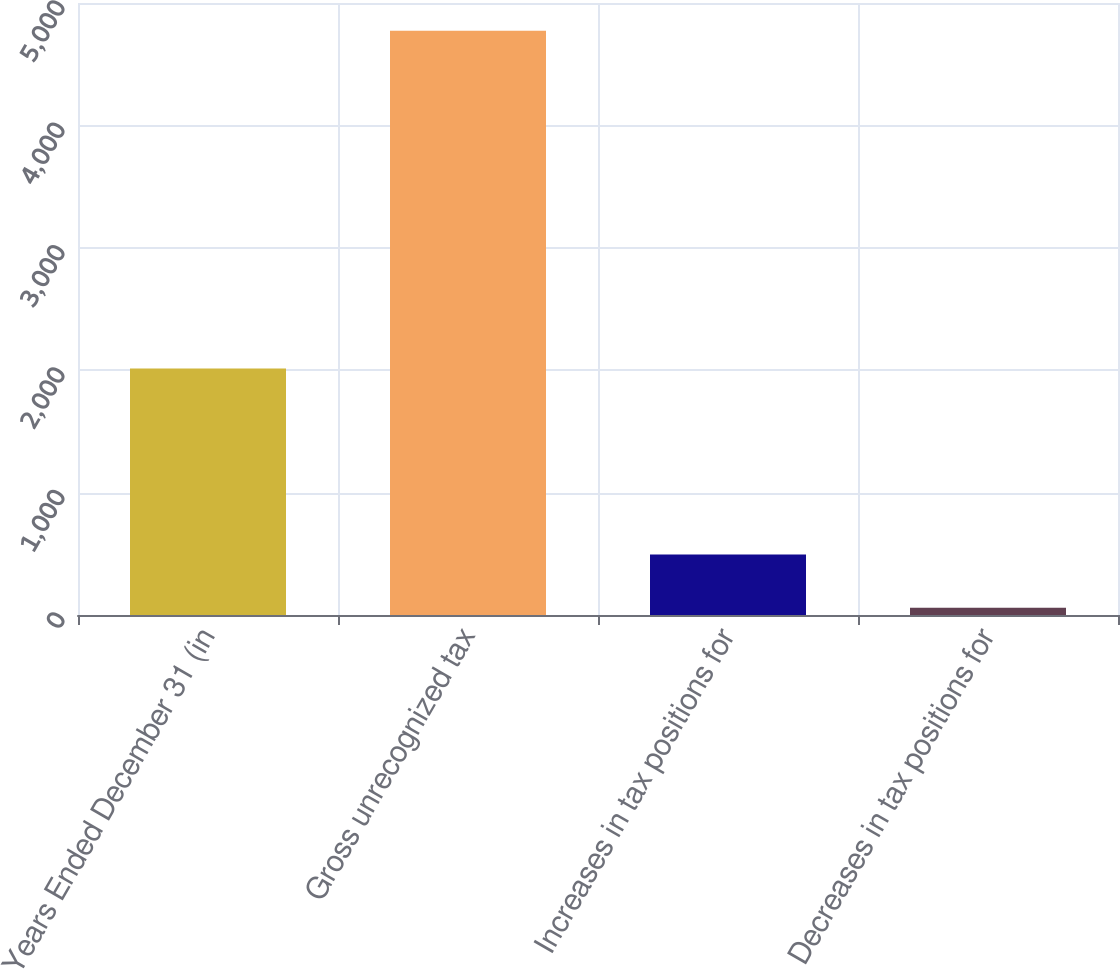<chart> <loc_0><loc_0><loc_500><loc_500><bar_chart><fcel>Years Ended December 31 (in<fcel>Gross unrecognized tax<fcel>Increases in tax positions for<fcel>Decreases in tax positions for<nl><fcel>2014<fcel>4773.5<fcel>493.5<fcel>60<nl></chart> 